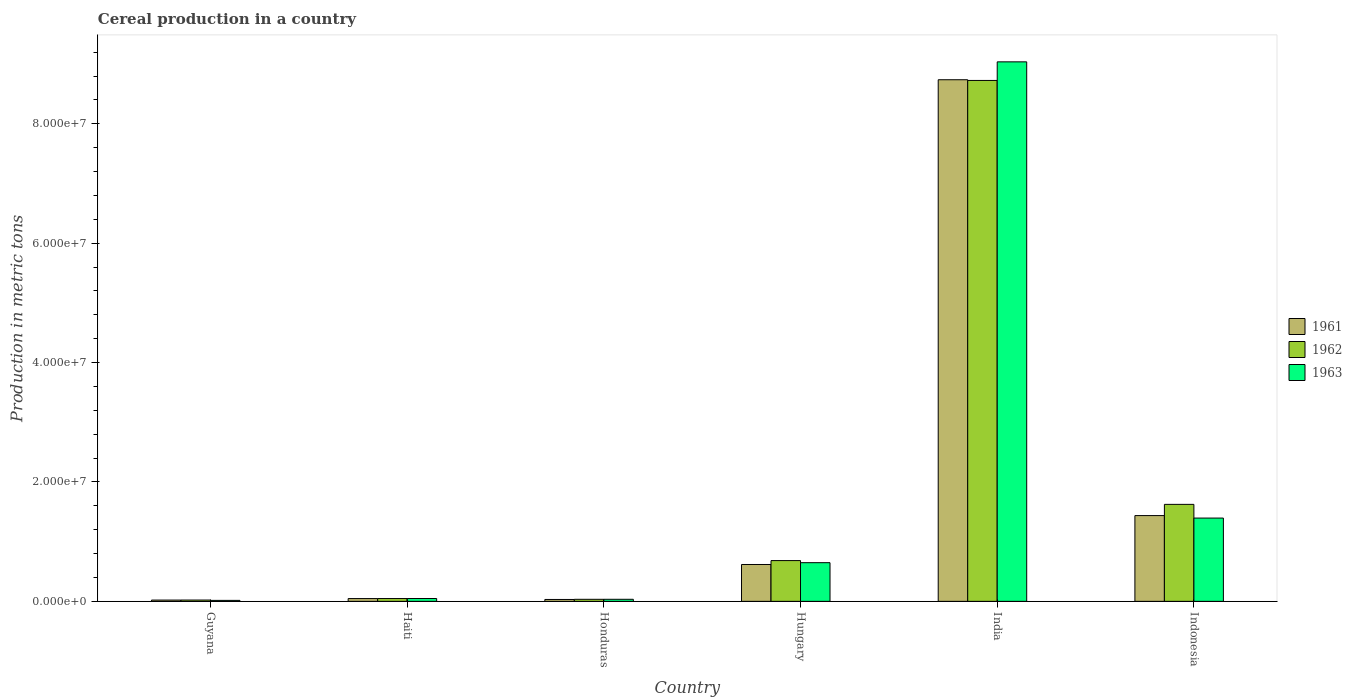How many different coloured bars are there?
Provide a short and direct response. 3. How many groups of bars are there?
Give a very brief answer. 6. Are the number of bars per tick equal to the number of legend labels?
Give a very brief answer. Yes. How many bars are there on the 1st tick from the left?
Keep it short and to the point. 3. How many bars are there on the 2nd tick from the right?
Give a very brief answer. 3. What is the label of the 2nd group of bars from the left?
Your answer should be compact. Haiti. In how many cases, is the number of bars for a given country not equal to the number of legend labels?
Offer a terse response. 0. What is the total cereal production in 1963 in Hungary?
Offer a very short reply. 6.48e+06. Across all countries, what is the maximum total cereal production in 1963?
Your answer should be compact. 9.04e+07. Across all countries, what is the minimum total cereal production in 1963?
Ensure brevity in your answer.  1.64e+05. In which country was the total cereal production in 1962 minimum?
Keep it short and to the point. Guyana. What is the total total cereal production in 1962 in the graph?
Keep it short and to the point. 1.11e+08. What is the difference between the total cereal production in 1962 in Honduras and that in Hungary?
Ensure brevity in your answer.  -6.49e+06. What is the difference between the total cereal production in 1961 in Guyana and the total cereal production in 1963 in India?
Ensure brevity in your answer.  -9.02e+07. What is the average total cereal production in 1961 per country?
Provide a succinct answer. 1.82e+07. What is the difference between the total cereal production of/in 1961 and total cereal production of/in 1962 in Indonesia?
Make the answer very short. -1.88e+06. What is the ratio of the total cereal production in 1961 in Honduras to that in Hungary?
Offer a very short reply. 0.05. Is the difference between the total cereal production in 1961 in Haiti and Honduras greater than the difference between the total cereal production in 1962 in Haiti and Honduras?
Make the answer very short. Yes. What is the difference between the highest and the second highest total cereal production in 1963?
Make the answer very short. 8.39e+07. What is the difference between the highest and the lowest total cereal production in 1961?
Keep it short and to the point. 8.72e+07. Is the sum of the total cereal production in 1962 in Honduras and India greater than the maximum total cereal production in 1961 across all countries?
Ensure brevity in your answer.  Yes. What does the 1st bar from the left in India represents?
Your answer should be compact. 1961. What does the 2nd bar from the right in Guyana represents?
Make the answer very short. 1962. Is it the case that in every country, the sum of the total cereal production in 1963 and total cereal production in 1962 is greater than the total cereal production in 1961?
Make the answer very short. Yes. Are all the bars in the graph horizontal?
Your answer should be compact. No. How many countries are there in the graph?
Offer a very short reply. 6. What is the difference between two consecutive major ticks on the Y-axis?
Your response must be concise. 2.00e+07. Does the graph contain grids?
Your response must be concise. No. Where does the legend appear in the graph?
Make the answer very short. Center right. What is the title of the graph?
Provide a short and direct response. Cereal production in a country. Does "2010" appear as one of the legend labels in the graph?
Make the answer very short. No. What is the label or title of the X-axis?
Your response must be concise. Country. What is the label or title of the Y-axis?
Offer a terse response. Production in metric tons. What is the Production in metric tons of 1961 in Guyana?
Your answer should be very brief. 2.16e+05. What is the Production in metric tons of 1962 in Guyana?
Provide a short and direct response. 2.22e+05. What is the Production in metric tons of 1963 in Guyana?
Make the answer very short. 1.64e+05. What is the Production in metric tons of 1961 in Haiti?
Make the answer very short. 4.66e+05. What is the Production in metric tons of 1962 in Haiti?
Your response must be concise. 4.72e+05. What is the Production in metric tons in 1963 in Haiti?
Your response must be concise. 4.78e+05. What is the Production in metric tons in 1961 in Honduras?
Provide a succinct answer. 3.18e+05. What is the Production in metric tons of 1962 in Honduras?
Give a very brief answer. 3.44e+05. What is the Production in metric tons of 1963 in Honduras?
Keep it short and to the point. 3.47e+05. What is the Production in metric tons in 1961 in Hungary?
Offer a very short reply. 6.17e+06. What is the Production in metric tons in 1962 in Hungary?
Your response must be concise. 6.83e+06. What is the Production in metric tons of 1963 in Hungary?
Provide a succinct answer. 6.48e+06. What is the Production in metric tons of 1961 in India?
Offer a terse response. 8.74e+07. What is the Production in metric tons in 1962 in India?
Offer a very short reply. 8.73e+07. What is the Production in metric tons of 1963 in India?
Give a very brief answer. 9.04e+07. What is the Production in metric tons in 1961 in Indonesia?
Your answer should be compact. 1.44e+07. What is the Production in metric tons in 1962 in Indonesia?
Offer a very short reply. 1.62e+07. What is the Production in metric tons in 1963 in Indonesia?
Your answer should be compact. 1.40e+07. Across all countries, what is the maximum Production in metric tons in 1961?
Make the answer very short. 8.74e+07. Across all countries, what is the maximum Production in metric tons of 1962?
Give a very brief answer. 8.73e+07. Across all countries, what is the maximum Production in metric tons in 1963?
Your response must be concise. 9.04e+07. Across all countries, what is the minimum Production in metric tons of 1961?
Give a very brief answer. 2.16e+05. Across all countries, what is the minimum Production in metric tons in 1962?
Your response must be concise. 2.22e+05. Across all countries, what is the minimum Production in metric tons of 1963?
Your answer should be very brief. 1.64e+05. What is the total Production in metric tons of 1961 in the graph?
Your response must be concise. 1.09e+08. What is the total Production in metric tons of 1962 in the graph?
Keep it short and to the point. 1.11e+08. What is the total Production in metric tons in 1963 in the graph?
Provide a succinct answer. 1.12e+08. What is the difference between the Production in metric tons in 1961 in Guyana and that in Haiti?
Give a very brief answer. -2.50e+05. What is the difference between the Production in metric tons in 1962 in Guyana and that in Haiti?
Make the answer very short. -2.51e+05. What is the difference between the Production in metric tons of 1963 in Guyana and that in Haiti?
Make the answer very short. -3.14e+05. What is the difference between the Production in metric tons of 1961 in Guyana and that in Honduras?
Offer a terse response. -1.02e+05. What is the difference between the Production in metric tons in 1962 in Guyana and that in Honduras?
Your response must be concise. -1.22e+05. What is the difference between the Production in metric tons in 1963 in Guyana and that in Honduras?
Give a very brief answer. -1.83e+05. What is the difference between the Production in metric tons in 1961 in Guyana and that in Hungary?
Your answer should be very brief. -5.96e+06. What is the difference between the Production in metric tons of 1962 in Guyana and that in Hungary?
Keep it short and to the point. -6.61e+06. What is the difference between the Production in metric tons in 1963 in Guyana and that in Hungary?
Make the answer very short. -6.31e+06. What is the difference between the Production in metric tons of 1961 in Guyana and that in India?
Provide a succinct answer. -8.72e+07. What is the difference between the Production in metric tons of 1962 in Guyana and that in India?
Provide a succinct answer. -8.70e+07. What is the difference between the Production in metric tons of 1963 in Guyana and that in India?
Keep it short and to the point. -9.02e+07. What is the difference between the Production in metric tons of 1961 in Guyana and that in Indonesia?
Give a very brief answer. -1.42e+07. What is the difference between the Production in metric tons in 1962 in Guyana and that in Indonesia?
Keep it short and to the point. -1.60e+07. What is the difference between the Production in metric tons in 1963 in Guyana and that in Indonesia?
Keep it short and to the point. -1.38e+07. What is the difference between the Production in metric tons in 1961 in Haiti and that in Honduras?
Make the answer very short. 1.48e+05. What is the difference between the Production in metric tons of 1962 in Haiti and that in Honduras?
Make the answer very short. 1.29e+05. What is the difference between the Production in metric tons in 1963 in Haiti and that in Honduras?
Ensure brevity in your answer.  1.31e+05. What is the difference between the Production in metric tons of 1961 in Haiti and that in Hungary?
Keep it short and to the point. -5.71e+06. What is the difference between the Production in metric tons of 1962 in Haiti and that in Hungary?
Provide a short and direct response. -6.36e+06. What is the difference between the Production in metric tons of 1963 in Haiti and that in Hungary?
Provide a succinct answer. -6.00e+06. What is the difference between the Production in metric tons in 1961 in Haiti and that in India?
Your answer should be compact. -8.69e+07. What is the difference between the Production in metric tons of 1962 in Haiti and that in India?
Keep it short and to the point. -8.68e+07. What is the difference between the Production in metric tons of 1963 in Haiti and that in India?
Your answer should be compact. -8.99e+07. What is the difference between the Production in metric tons in 1961 in Haiti and that in Indonesia?
Offer a terse response. -1.39e+07. What is the difference between the Production in metric tons of 1962 in Haiti and that in Indonesia?
Your response must be concise. -1.58e+07. What is the difference between the Production in metric tons of 1963 in Haiti and that in Indonesia?
Keep it short and to the point. -1.35e+07. What is the difference between the Production in metric tons of 1961 in Honduras and that in Hungary?
Provide a succinct answer. -5.86e+06. What is the difference between the Production in metric tons in 1962 in Honduras and that in Hungary?
Give a very brief answer. -6.49e+06. What is the difference between the Production in metric tons in 1963 in Honduras and that in Hungary?
Provide a succinct answer. -6.13e+06. What is the difference between the Production in metric tons of 1961 in Honduras and that in India?
Offer a very short reply. -8.71e+07. What is the difference between the Production in metric tons of 1962 in Honduras and that in India?
Ensure brevity in your answer.  -8.69e+07. What is the difference between the Production in metric tons of 1963 in Honduras and that in India?
Provide a short and direct response. -9.00e+07. What is the difference between the Production in metric tons in 1961 in Honduras and that in Indonesia?
Provide a short and direct response. -1.40e+07. What is the difference between the Production in metric tons of 1962 in Honduras and that in Indonesia?
Your answer should be very brief. -1.59e+07. What is the difference between the Production in metric tons of 1963 in Honduras and that in Indonesia?
Your answer should be compact. -1.36e+07. What is the difference between the Production in metric tons of 1961 in Hungary and that in India?
Keep it short and to the point. -8.12e+07. What is the difference between the Production in metric tons of 1962 in Hungary and that in India?
Provide a short and direct response. -8.04e+07. What is the difference between the Production in metric tons in 1963 in Hungary and that in India?
Your response must be concise. -8.39e+07. What is the difference between the Production in metric tons of 1961 in Hungary and that in Indonesia?
Offer a terse response. -8.19e+06. What is the difference between the Production in metric tons in 1962 in Hungary and that in Indonesia?
Your answer should be compact. -9.42e+06. What is the difference between the Production in metric tons in 1963 in Hungary and that in Indonesia?
Your answer should be very brief. -7.47e+06. What is the difference between the Production in metric tons of 1961 in India and that in Indonesia?
Give a very brief answer. 7.30e+07. What is the difference between the Production in metric tons of 1962 in India and that in Indonesia?
Your answer should be very brief. 7.10e+07. What is the difference between the Production in metric tons of 1963 in India and that in Indonesia?
Offer a terse response. 7.64e+07. What is the difference between the Production in metric tons of 1961 in Guyana and the Production in metric tons of 1962 in Haiti?
Offer a very short reply. -2.56e+05. What is the difference between the Production in metric tons in 1961 in Guyana and the Production in metric tons in 1963 in Haiti?
Provide a short and direct response. -2.62e+05. What is the difference between the Production in metric tons of 1962 in Guyana and the Production in metric tons of 1963 in Haiti?
Offer a very short reply. -2.56e+05. What is the difference between the Production in metric tons in 1961 in Guyana and the Production in metric tons in 1962 in Honduras?
Your answer should be compact. -1.27e+05. What is the difference between the Production in metric tons in 1961 in Guyana and the Production in metric tons in 1963 in Honduras?
Offer a very short reply. -1.31e+05. What is the difference between the Production in metric tons of 1962 in Guyana and the Production in metric tons of 1963 in Honduras?
Offer a terse response. -1.25e+05. What is the difference between the Production in metric tons in 1961 in Guyana and the Production in metric tons in 1962 in Hungary?
Provide a succinct answer. -6.61e+06. What is the difference between the Production in metric tons in 1961 in Guyana and the Production in metric tons in 1963 in Hungary?
Offer a very short reply. -6.26e+06. What is the difference between the Production in metric tons in 1962 in Guyana and the Production in metric tons in 1963 in Hungary?
Offer a terse response. -6.26e+06. What is the difference between the Production in metric tons of 1961 in Guyana and the Production in metric tons of 1962 in India?
Offer a terse response. -8.70e+07. What is the difference between the Production in metric tons in 1961 in Guyana and the Production in metric tons in 1963 in India?
Your answer should be very brief. -9.02e+07. What is the difference between the Production in metric tons of 1962 in Guyana and the Production in metric tons of 1963 in India?
Give a very brief answer. -9.02e+07. What is the difference between the Production in metric tons in 1961 in Guyana and the Production in metric tons in 1962 in Indonesia?
Keep it short and to the point. -1.60e+07. What is the difference between the Production in metric tons in 1961 in Guyana and the Production in metric tons in 1963 in Indonesia?
Your answer should be very brief. -1.37e+07. What is the difference between the Production in metric tons in 1962 in Guyana and the Production in metric tons in 1963 in Indonesia?
Provide a succinct answer. -1.37e+07. What is the difference between the Production in metric tons of 1961 in Haiti and the Production in metric tons of 1962 in Honduras?
Provide a succinct answer. 1.22e+05. What is the difference between the Production in metric tons in 1961 in Haiti and the Production in metric tons in 1963 in Honduras?
Offer a very short reply. 1.19e+05. What is the difference between the Production in metric tons in 1962 in Haiti and the Production in metric tons in 1963 in Honduras?
Offer a terse response. 1.25e+05. What is the difference between the Production in metric tons of 1961 in Haiti and the Production in metric tons of 1962 in Hungary?
Your response must be concise. -6.36e+06. What is the difference between the Production in metric tons of 1961 in Haiti and the Production in metric tons of 1963 in Hungary?
Your answer should be very brief. -6.01e+06. What is the difference between the Production in metric tons in 1962 in Haiti and the Production in metric tons in 1963 in Hungary?
Give a very brief answer. -6.01e+06. What is the difference between the Production in metric tons of 1961 in Haiti and the Production in metric tons of 1962 in India?
Your answer should be very brief. -8.68e+07. What is the difference between the Production in metric tons in 1961 in Haiti and the Production in metric tons in 1963 in India?
Make the answer very short. -8.99e+07. What is the difference between the Production in metric tons of 1962 in Haiti and the Production in metric tons of 1963 in India?
Ensure brevity in your answer.  -8.99e+07. What is the difference between the Production in metric tons of 1961 in Haiti and the Production in metric tons of 1962 in Indonesia?
Offer a very short reply. -1.58e+07. What is the difference between the Production in metric tons in 1961 in Haiti and the Production in metric tons in 1963 in Indonesia?
Give a very brief answer. -1.35e+07. What is the difference between the Production in metric tons of 1962 in Haiti and the Production in metric tons of 1963 in Indonesia?
Make the answer very short. -1.35e+07. What is the difference between the Production in metric tons of 1961 in Honduras and the Production in metric tons of 1962 in Hungary?
Your answer should be compact. -6.51e+06. What is the difference between the Production in metric tons in 1961 in Honduras and the Production in metric tons in 1963 in Hungary?
Your response must be concise. -6.16e+06. What is the difference between the Production in metric tons of 1962 in Honduras and the Production in metric tons of 1963 in Hungary?
Ensure brevity in your answer.  -6.14e+06. What is the difference between the Production in metric tons of 1961 in Honduras and the Production in metric tons of 1962 in India?
Provide a short and direct response. -8.69e+07. What is the difference between the Production in metric tons of 1961 in Honduras and the Production in metric tons of 1963 in India?
Offer a very short reply. -9.01e+07. What is the difference between the Production in metric tons in 1962 in Honduras and the Production in metric tons in 1963 in India?
Offer a very short reply. -9.00e+07. What is the difference between the Production in metric tons of 1961 in Honduras and the Production in metric tons of 1962 in Indonesia?
Ensure brevity in your answer.  -1.59e+07. What is the difference between the Production in metric tons of 1961 in Honduras and the Production in metric tons of 1963 in Indonesia?
Keep it short and to the point. -1.36e+07. What is the difference between the Production in metric tons in 1962 in Honduras and the Production in metric tons in 1963 in Indonesia?
Offer a very short reply. -1.36e+07. What is the difference between the Production in metric tons in 1961 in Hungary and the Production in metric tons in 1962 in India?
Give a very brief answer. -8.11e+07. What is the difference between the Production in metric tons of 1961 in Hungary and the Production in metric tons of 1963 in India?
Give a very brief answer. -8.42e+07. What is the difference between the Production in metric tons of 1962 in Hungary and the Production in metric tons of 1963 in India?
Offer a terse response. -8.35e+07. What is the difference between the Production in metric tons in 1961 in Hungary and the Production in metric tons in 1962 in Indonesia?
Make the answer very short. -1.01e+07. What is the difference between the Production in metric tons in 1961 in Hungary and the Production in metric tons in 1963 in Indonesia?
Ensure brevity in your answer.  -7.78e+06. What is the difference between the Production in metric tons in 1962 in Hungary and the Production in metric tons in 1963 in Indonesia?
Your answer should be very brief. -7.12e+06. What is the difference between the Production in metric tons in 1961 in India and the Production in metric tons in 1962 in Indonesia?
Your response must be concise. 7.11e+07. What is the difference between the Production in metric tons in 1961 in India and the Production in metric tons in 1963 in Indonesia?
Your answer should be very brief. 7.34e+07. What is the difference between the Production in metric tons of 1962 in India and the Production in metric tons of 1963 in Indonesia?
Your answer should be very brief. 7.33e+07. What is the average Production in metric tons in 1961 per country?
Keep it short and to the point. 1.82e+07. What is the average Production in metric tons of 1962 per country?
Ensure brevity in your answer.  1.86e+07. What is the average Production in metric tons in 1963 per country?
Keep it short and to the point. 1.86e+07. What is the difference between the Production in metric tons of 1961 and Production in metric tons of 1962 in Guyana?
Keep it short and to the point. -5445. What is the difference between the Production in metric tons in 1961 and Production in metric tons in 1963 in Guyana?
Offer a terse response. 5.19e+04. What is the difference between the Production in metric tons of 1962 and Production in metric tons of 1963 in Guyana?
Your answer should be compact. 5.74e+04. What is the difference between the Production in metric tons of 1961 and Production in metric tons of 1962 in Haiti?
Make the answer very short. -6500. What is the difference between the Production in metric tons in 1961 and Production in metric tons in 1963 in Haiti?
Your response must be concise. -1.20e+04. What is the difference between the Production in metric tons of 1962 and Production in metric tons of 1963 in Haiti?
Your response must be concise. -5500. What is the difference between the Production in metric tons in 1961 and Production in metric tons in 1962 in Honduras?
Offer a terse response. -2.57e+04. What is the difference between the Production in metric tons in 1961 and Production in metric tons in 1963 in Honduras?
Offer a very short reply. -2.92e+04. What is the difference between the Production in metric tons in 1962 and Production in metric tons in 1963 in Honduras?
Your answer should be very brief. -3541. What is the difference between the Production in metric tons in 1961 and Production in metric tons in 1962 in Hungary?
Your answer should be very brief. -6.55e+05. What is the difference between the Production in metric tons of 1961 and Production in metric tons of 1963 in Hungary?
Your response must be concise. -3.04e+05. What is the difference between the Production in metric tons of 1962 and Production in metric tons of 1963 in Hungary?
Provide a short and direct response. 3.51e+05. What is the difference between the Production in metric tons of 1961 and Production in metric tons of 1962 in India?
Ensure brevity in your answer.  1.19e+05. What is the difference between the Production in metric tons in 1961 and Production in metric tons in 1963 in India?
Your answer should be very brief. -3.00e+06. What is the difference between the Production in metric tons of 1962 and Production in metric tons of 1963 in India?
Your response must be concise. -3.12e+06. What is the difference between the Production in metric tons of 1961 and Production in metric tons of 1962 in Indonesia?
Provide a short and direct response. -1.88e+06. What is the difference between the Production in metric tons in 1961 and Production in metric tons in 1963 in Indonesia?
Offer a terse response. 4.14e+05. What is the difference between the Production in metric tons in 1962 and Production in metric tons in 1963 in Indonesia?
Your answer should be compact. 2.29e+06. What is the ratio of the Production in metric tons in 1961 in Guyana to that in Haiti?
Offer a terse response. 0.46. What is the ratio of the Production in metric tons in 1962 in Guyana to that in Haiti?
Give a very brief answer. 0.47. What is the ratio of the Production in metric tons of 1963 in Guyana to that in Haiti?
Your answer should be compact. 0.34. What is the ratio of the Production in metric tons of 1961 in Guyana to that in Honduras?
Ensure brevity in your answer.  0.68. What is the ratio of the Production in metric tons in 1962 in Guyana to that in Honduras?
Ensure brevity in your answer.  0.65. What is the ratio of the Production in metric tons in 1963 in Guyana to that in Honduras?
Your answer should be very brief. 0.47. What is the ratio of the Production in metric tons of 1961 in Guyana to that in Hungary?
Keep it short and to the point. 0.04. What is the ratio of the Production in metric tons in 1962 in Guyana to that in Hungary?
Your answer should be very brief. 0.03. What is the ratio of the Production in metric tons in 1963 in Guyana to that in Hungary?
Ensure brevity in your answer.  0.03. What is the ratio of the Production in metric tons of 1961 in Guyana to that in India?
Offer a terse response. 0. What is the ratio of the Production in metric tons of 1962 in Guyana to that in India?
Provide a short and direct response. 0. What is the ratio of the Production in metric tons in 1963 in Guyana to that in India?
Give a very brief answer. 0. What is the ratio of the Production in metric tons in 1961 in Guyana to that in Indonesia?
Your answer should be compact. 0.02. What is the ratio of the Production in metric tons in 1962 in Guyana to that in Indonesia?
Your answer should be very brief. 0.01. What is the ratio of the Production in metric tons in 1963 in Guyana to that in Indonesia?
Ensure brevity in your answer.  0.01. What is the ratio of the Production in metric tons of 1961 in Haiti to that in Honduras?
Your response must be concise. 1.47. What is the ratio of the Production in metric tons of 1962 in Haiti to that in Honduras?
Your response must be concise. 1.37. What is the ratio of the Production in metric tons in 1963 in Haiti to that in Honduras?
Keep it short and to the point. 1.38. What is the ratio of the Production in metric tons in 1961 in Haiti to that in Hungary?
Provide a succinct answer. 0.08. What is the ratio of the Production in metric tons of 1962 in Haiti to that in Hungary?
Make the answer very short. 0.07. What is the ratio of the Production in metric tons of 1963 in Haiti to that in Hungary?
Ensure brevity in your answer.  0.07. What is the ratio of the Production in metric tons in 1961 in Haiti to that in India?
Offer a terse response. 0.01. What is the ratio of the Production in metric tons in 1962 in Haiti to that in India?
Offer a very short reply. 0.01. What is the ratio of the Production in metric tons in 1963 in Haiti to that in India?
Ensure brevity in your answer.  0.01. What is the ratio of the Production in metric tons of 1961 in Haiti to that in Indonesia?
Provide a succinct answer. 0.03. What is the ratio of the Production in metric tons in 1962 in Haiti to that in Indonesia?
Your answer should be very brief. 0.03. What is the ratio of the Production in metric tons in 1963 in Haiti to that in Indonesia?
Your answer should be compact. 0.03. What is the ratio of the Production in metric tons of 1961 in Honduras to that in Hungary?
Offer a terse response. 0.05. What is the ratio of the Production in metric tons in 1962 in Honduras to that in Hungary?
Make the answer very short. 0.05. What is the ratio of the Production in metric tons in 1963 in Honduras to that in Hungary?
Your answer should be very brief. 0.05. What is the ratio of the Production in metric tons of 1961 in Honduras to that in India?
Provide a short and direct response. 0. What is the ratio of the Production in metric tons in 1962 in Honduras to that in India?
Offer a terse response. 0. What is the ratio of the Production in metric tons of 1963 in Honduras to that in India?
Your response must be concise. 0. What is the ratio of the Production in metric tons in 1961 in Honduras to that in Indonesia?
Offer a terse response. 0.02. What is the ratio of the Production in metric tons of 1962 in Honduras to that in Indonesia?
Keep it short and to the point. 0.02. What is the ratio of the Production in metric tons of 1963 in Honduras to that in Indonesia?
Provide a short and direct response. 0.02. What is the ratio of the Production in metric tons in 1961 in Hungary to that in India?
Ensure brevity in your answer.  0.07. What is the ratio of the Production in metric tons of 1962 in Hungary to that in India?
Give a very brief answer. 0.08. What is the ratio of the Production in metric tons in 1963 in Hungary to that in India?
Provide a succinct answer. 0.07. What is the ratio of the Production in metric tons in 1961 in Hungary to that in Indonesia?
Offer a terse response. 0.43. What is the ratio of the Production in metric tons of 1962 in Hungary to that in Indonesia?
Your answer should be compact. 0.42. What is the ratio of the Production in metric tons in 1963 in Hungary to that in Indonesia?
Make the answer very short. 0.46. What is the ratio of the Production in metric tons in 1961 in India to that in Indonesia?
Make the answer very short. 6.08. What is the ratio of the Production in metric tons in 1962 in India to that in Indonesia?
Your answer should be very brief. 5.37. What is the ratio of the Production in metric tons in 1963 in India to that in Indonesia?
Give a very brief answer. 6.48. What is the difference between the highest and the second highest Production in metric tons of 1961?
Ensure brevity in your answer.  7.30e+07. What is the difference between the highest and the second highest Production in metric tons of 1962?
Offer a very short reply. 7.10e+07. What is the difference between the highest and the second highest Production in metric tons in 1963?
Keep it short and to the point. 7.64e+07. What is the difference between the highest and the lowest Production in metric tons in 1961?
Provide a short and direct response. 8.72e+07. What is the difference between the highest and the lowest Production in metric tons in 1962?
Offer a terse response. 8.70e+07. What is the difference between the highest and the lowest Production in metric tons of 1963?
Your response must be concise. 9.02e+07. 